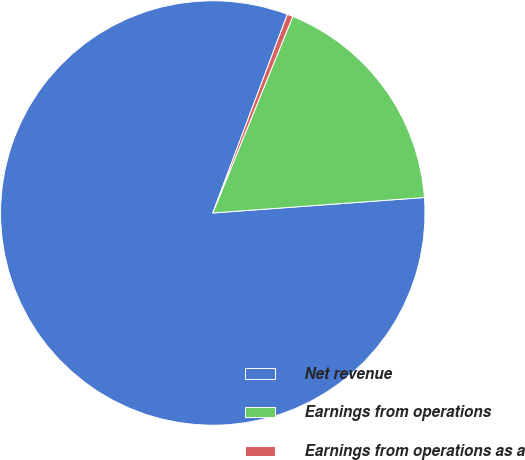<chart> <loc_0><loc_0><loc_500><loc_500><pie_chart><fcel>Net revenue<fcel>Earnings from operations<fcel>Earnings from operations as a<nl><fcel>81.88%<fcel>17.68%<fcel>0.44%<nl></chart> 